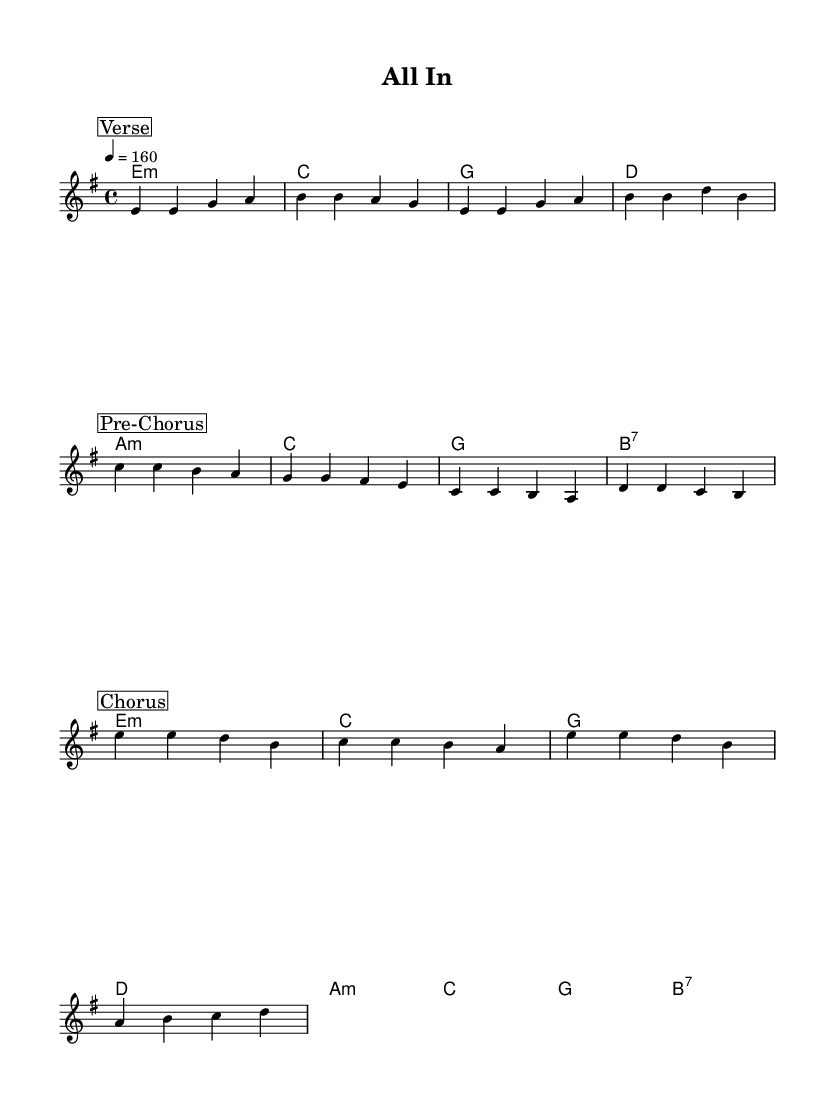What is the key signature of this music? The key signature is identified by the symbols placed at the beginning of the staff, which indicate E minor. This key signature has one sharp (F#).
Answer: E minor What is the time signature of this music? The time signature is indicated by the fraction-like number at the beginning of the piece, which shows there are 4 beats in each measure and the quarter note gets one beat.
Answer: 4/4 What is the tempo marking for this piece? The tempo marking is found at the beginning of the score, where it indicates a speed of 160 beats per minute (indicated as 4 = 160).
Answer: 160 How many distinct sections does this piece have? By examining the structure marked in the music, there are three distinct sections labeled as "Verse," "Pre-Chorus," and "Chorus."
Answer: 3 What type of chords are predominantly used in the harmony? The chord progression shown in the score reveals a combination of minor and major chords, with the presence of a seventh chord (B7) towards the end.
Answer: Minor and Major What is the last note of the chorus section? Looking at the chorus section, the last note is identified by the final note in the measure corresponding to the chorus part. The last note shown is D.
Answer: D In which section does the melody start on the note E? The melody starting on the note E is found in the "Verse" section, where the first note is E in the initial measure.
Answer: Verse 